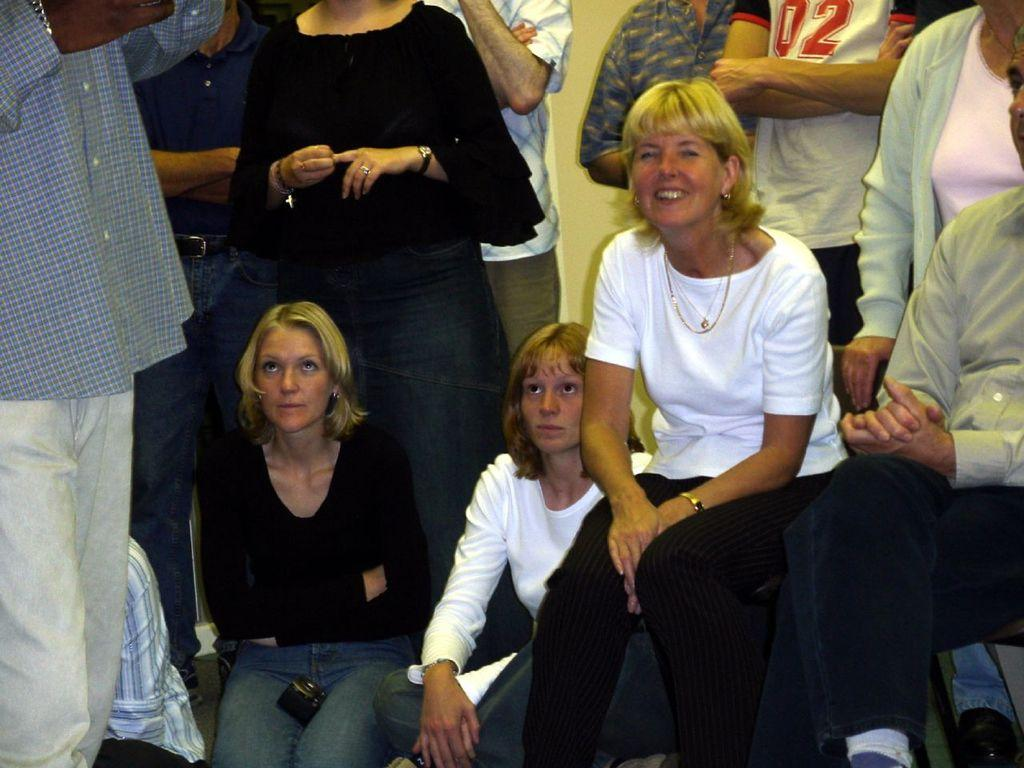What is the composition of the group in the image? There is a group of people in the image. What positions are some of the people in the group taking? Some people in the group are standing, while others are sitting. What type of queen can be seen in the image? There is no queen present in the image; it features a group of people. What type of smoke can be seen coming from the people in the image? There is no smoke present in the image; it features a group of people standing and sitting. 